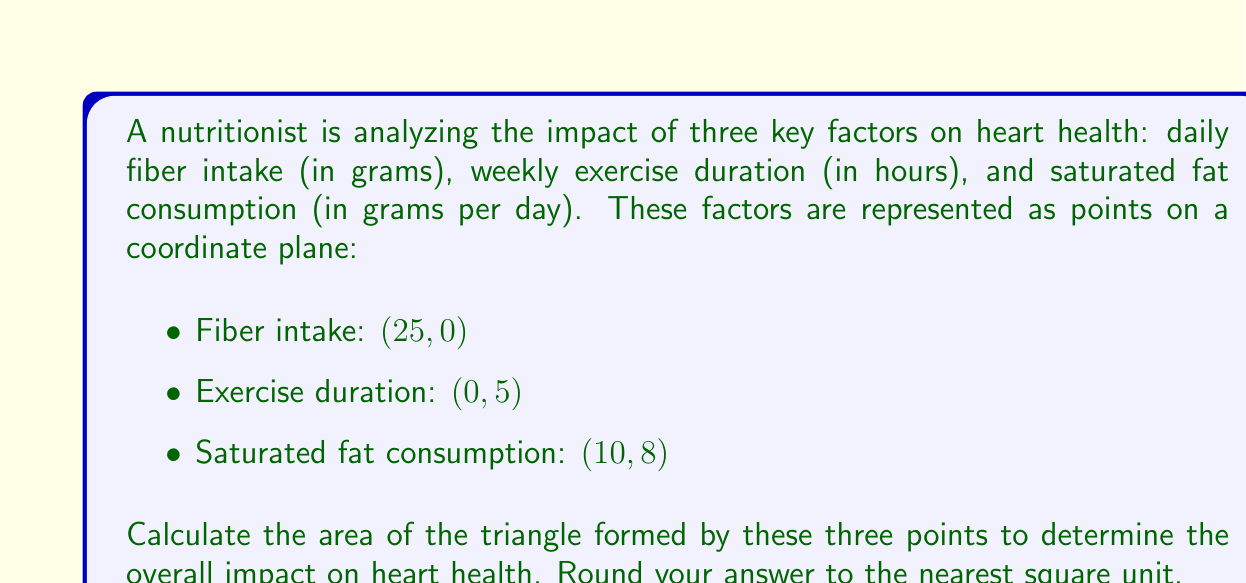Teach me how to tackle this problem. To calculate the area of a triangle formed by three points, we can use the formula:

$$\text{Area} = \frac{1}{2}|x_1(y_2 - y_3) + x_2(y_3 - y_1) + x_3(y_1 - y_2)|$$

Where $(x_1, y_1)$, $(x_2, y_2)$, and $(x_3, y_3)$ are the coordinates of the three points.

Let's assign our points:
$(x_1, y_1) = (25, 0)$ (Fiber intake)
$(x_2, y_2) = (0, 5)$ (Exercise duration)
$(x_3, y_3) = (10, 8)$ (Saturated fat consumption)

Now, let's substitute these values into the formula:

$$\begin{align}
\text{Area} &= \frac{1}{2}|25(5 - 8) + 0(8 - 0) + 10(0 - 5)| \\
&= \frac{1}{2}|25(-3) + 0 + 10(-5)| \\
&= \frac{1}{2}|-75 - 50| \\
&= \frac{1}{2}|-125| \\
&= \frac{1}{2}(125) \\
&= 62.5
\end{align}$$

Rounding to the nearest square unit:

$$\text{Area} \approx 63 \text{ square units}$$

[asy]
unitsize(10);
draw((0,0)--(30,0), arrow=Arrow());
draw((0,0)--(0,10), arrow=Arrow());
dot((25,0));
dot((0,5));
dot((10,8));
draw((25,0)--(0,5)--(10,8)--cycle);
label("Fiber intake (25, 0)", (25,0), S);
label("Exercise (0, 5)", (0,5), W);
label("Sat. fat (10, 8)", (10,8), NE);
label("x", (30,0), E);
label("y", (0,10), N);
[/asy]
Answer: 63 square units 